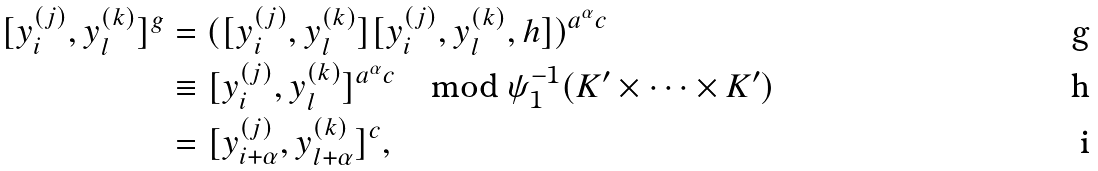<formula> <loc_0><loc_0><loc_500><loc_500>[ y ^ { ( j ) } _ { i } , y ^ { ( k ) } _ { l } ] ^ { g } & = ( [ y ^ { ( j ) } _ { i } , y ^ { ( k ) } _ { l } ] [ y ^ { ( j ) } _ { i } , y ^ { ( k ) } _ { l } , h ] ) ^ { a ^ { \alpha } c } \\ & \equiv [ y ^ { ( j ) } _ { i } , y ^ { ( k ) } _ { l } ] ^ { a ^ { \alpha } c } \quad \text {mod } \psi _ { 1 } ^ { - 1 } ( K ^ { \prime } \times \dots \times K ^ { \prime } ) \\ & = [ y ^ { ( j ) } _ { i + \alpha } , y ^ { ( k ) } _ { l + \alpha } ] ^ { c } ,</formula> 